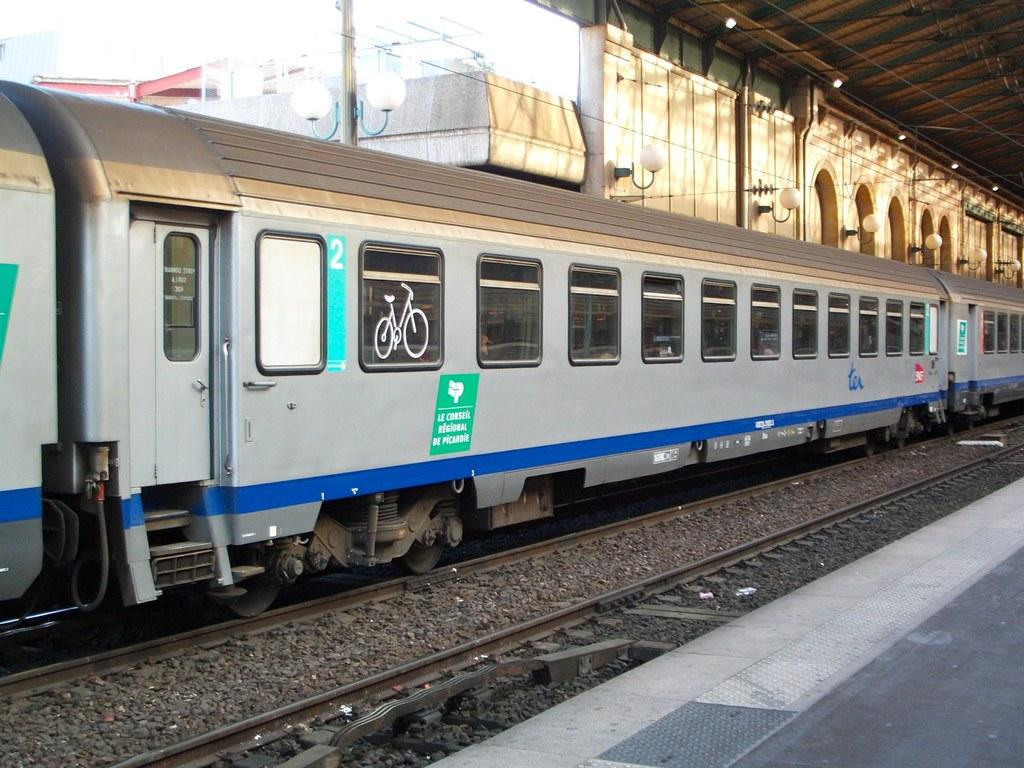What mode of transportation can be seen in the image? There is a train on the track in the image. What other elements are visible in the image besides the train? There are lights and a building visible in the image. Where is the train located in the image? The train is on the railway track. What is the purpose of the railway platform in the image? The railway platform is present in the image for passengers to board or disembark from the train. What type of star can be seen on the police officer's uniform in the image? There are no police officers or stars present in the image; it features a train on the track, lights, a building, and a railway platform. 